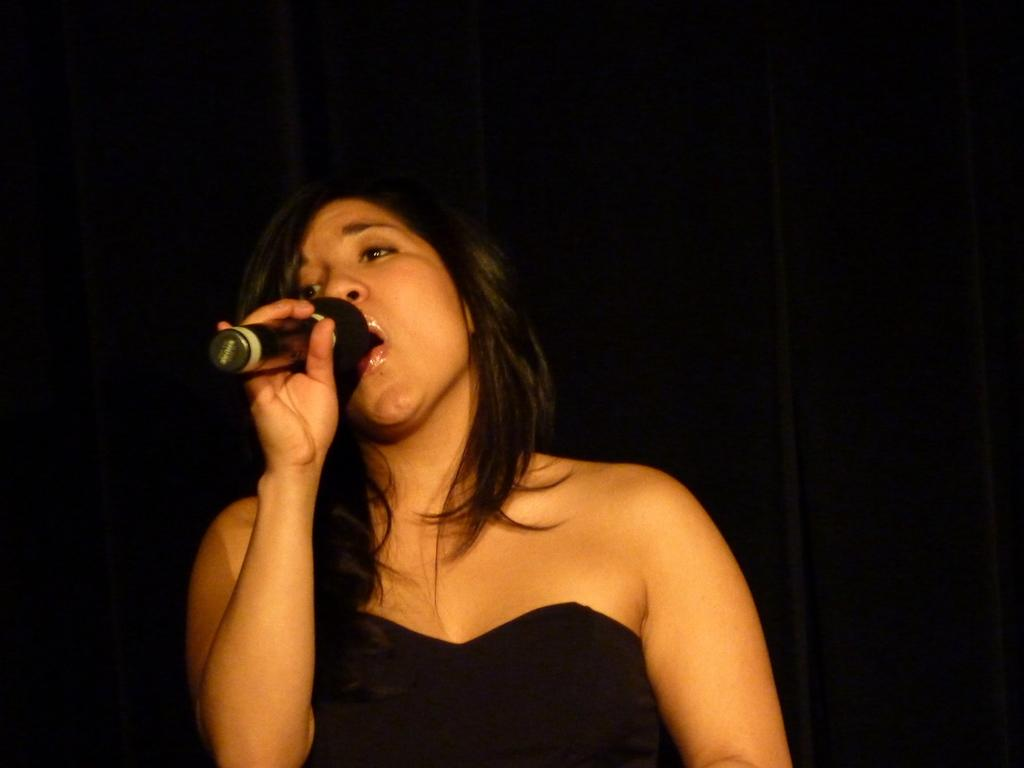What is the main subject of the image? The main subject of the image is a woman. What is the woman doing in the image? The woman is singing a song in the image. What object is the woman standing in front of? The woman is standing in front of a microphone in the image. What can be observed about the woman's mouth? The woman's mouth is open in the image. How would you describe the background of the image? The background of the image is dark. What color is the woman's dress? The woman is wearing a black dress in the image. Can you see a pig in the image? No, there is no pig present in the image. Is the woman holding a whip in the image? No, the woman is not holding a whip in the image. 